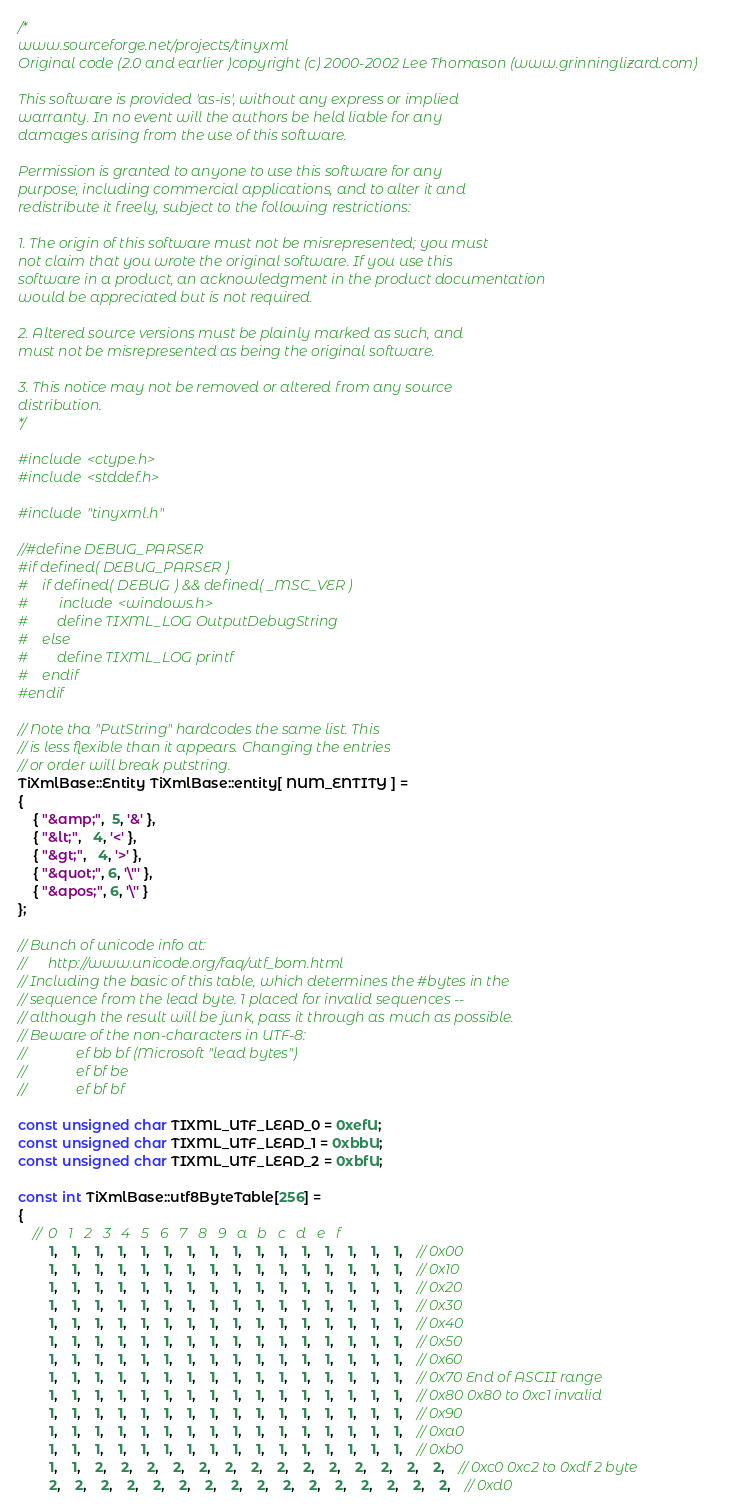Convert code to text. <code><loc_0><loc_0><loc_500><loc_500><_C++_>/*
www.sourceforge.net/projects/tinyxml
Original code (2.0 and earlier )copyright (c) 2000-2002 Lee Thomason (www.grinninglizard.com)

This software is provided 'as-is', without any express or implied 
warranty. In no event will the authors be held liable for any 
damages arising from the use of this software.

Permission is granted to anyone to use this software for any 
purpose, including commercial applications, and to alter it and 
redistribute it freely, subject to the following restrictions:

1. The origin of this software must not be misrepresented; you must 
not claim that you wrote the original software. If you use this
software in a product, an acknowledgment in the product documentation
would be appreciated but is not required.

2. Altered source versions must be plainly marked as such, and 
must not be misrepresented as being the original software.

3. This notice may not be removed or altered from any source 
distribution.
*/

#include <ctype.h>
#include <stddef.h>

#include "tinyxml.h"

//#define DEBUG_PARSER
#if defined( DEBUG_PARSER )
#	if defined( DEBUG ) && defined( _MSC_VER )
#		include <windows.h>
#		define TIXML_LOG OutputDebugString
#	else
#		define TIXML_LOG printf
#	endif
#endif

// Note tha "PutString" hardcodes the same list. This
// is less flexible than it appears. Changing the entries
// or order will break putstring.	
TiXmlBase::Entity TiXmlBase::entity[ NUM_ENTITY ] = 
{
	{ "&amp;",  5, '&' },
	{ "&lt;",   4, '<' },
	{ "&gt;",   4, '>' },
	{ "&quot;", 6, '\"' },
	{ "&apos;", 6, '\'' }
};

// Bunch of unicode info at:
//		http://www.unicode.org/faq/utf_bom.html
// Including the basic of this table, which determines the #bytes in the
// sequence from the lead byte. 1 placed for invalid sequences --
// although the result will be junk, pass it through as much as possible.
// Beware of the non-characters in UTF-8:	
//				ef bb bf (Microsoft "lead bytes")
//				ef bf be
//				ef bf bf 

const unsigned char TIXML_UTF_LEAD_0 = 0xefU;
const unsigned char TIXML_UTF_LEAD_1 = 0xbbU;
const unsigned char TIXML_UTF_LEAD_2 = 0xbfU;

const int TiXmlBase::utf8ByteTable[256] = 
{
	//	0	1	2	3	4	5	6	7	8	9	a	b	c	d	e	f
		1,	1,	1,	1,	1,	1,	1,	1,	1,	1,	1,	1,	1,	1,	1,	1,	// 0x00
		1,	1,	1,	1,	1,	1,	1,	1,	1,	1,	1,	1,	1,	1,	1,	1,	// 0x10
		1,	1,	1,	1,	1,	1,	1,	1,	1,	1,	1,	1,	1,	1,	1,	1,	// 0x20
		1,	1,	1,	1,	1,	1,	1,	1,	1,	1,	1,	1,	1,	1,	1,	1,	// 0x30
		1,	1,	1,	1,	1,	1,	1,	1,	1,	1,	1,	1,	1,	1,	1,	1,	// 0x40
		1,	1,	1,	1,	1,	1,	1,	1,	1,	1,	1,	1,	1,	1,	1,	1,	// 0x50
		1,	1,	1,	1,	1,	1,	1,	1,	1,	1,	1,	1,	1,	1,	1,	1,	// 0x60
		1,	1,	1,	1,	1,	1,	1,	1,	1,	1,	1,	1,	1,	1,	1,	1,	// 0x70	End of ASCII range
		1,	1,	1,	1,	1,	1,	1,	1,	1,	1,	1,	1,	1,	1,	1,	1,	// 0x80 0x80 to 0xc1 invalid
		1,	1,	1,	1,	1,	1,	1,	1,	1,	1,	1,	1,	1,	1,	1,	1,	// 0x90 
		1,	1,	1,	1,	1,	1,	1,	1,	1,	1,	1,	1,	1,	1,	1,	1,	// 0xa0 
		1,	1,	1,	1,	1,	1,	1,	1,	1,	1,	1,	1,	1,	1,	1,	1,	// 0xb0 
		1,	1,	2,	2,	2,	2,	2,	2,	2,	2,	2,	2,	2,	2,	2,	2,	// 0xc0 0xc2 to 0xdf 2 byte
		2,	2,	2,	2,	2,	2,	2,	2,	2,	2,	2,	2,	2,	2,	2,	2,	// 0xd0</code> 